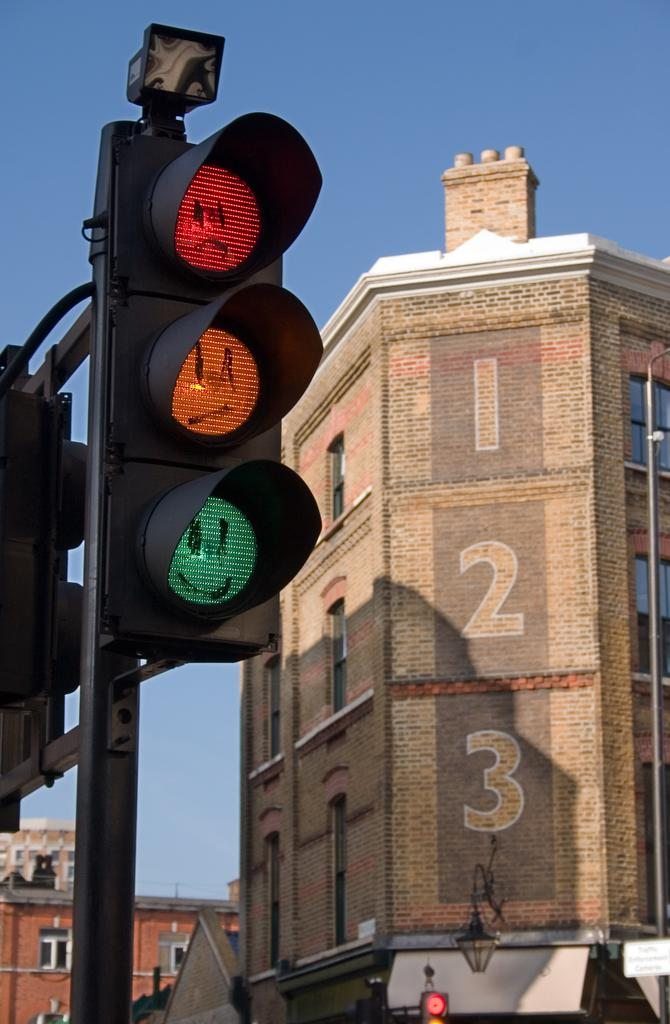Provide a one-sentence caption for the provided image. A brick building has the numbers 1, 2, 3 down the side. 